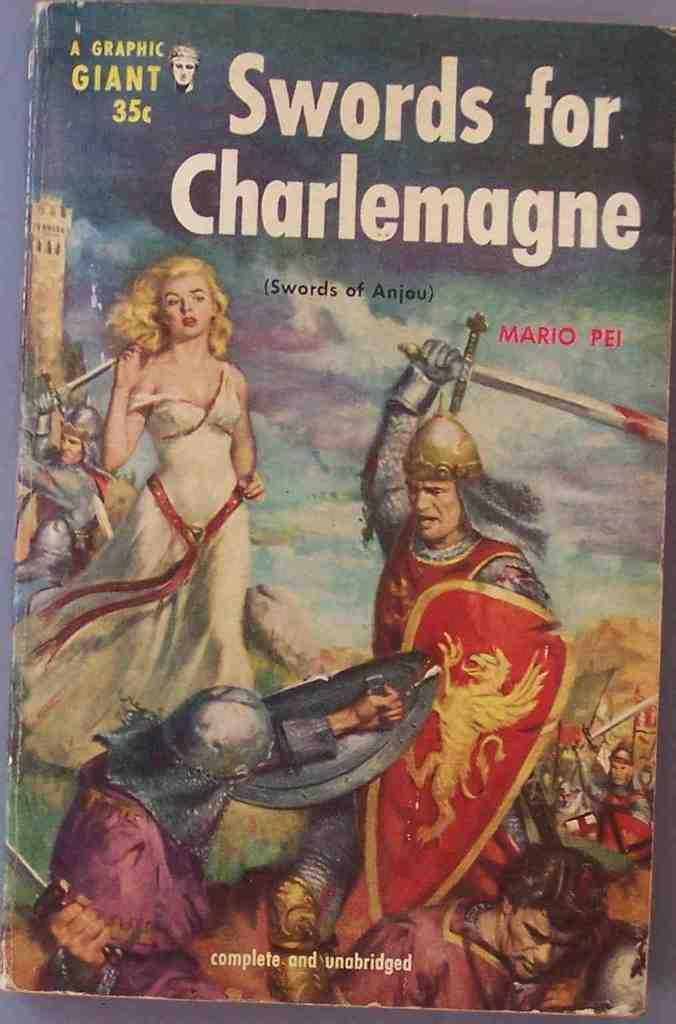<image>
Describe the image concisely. A book with a woman in a white dress on it is priced at thirty five cents. 